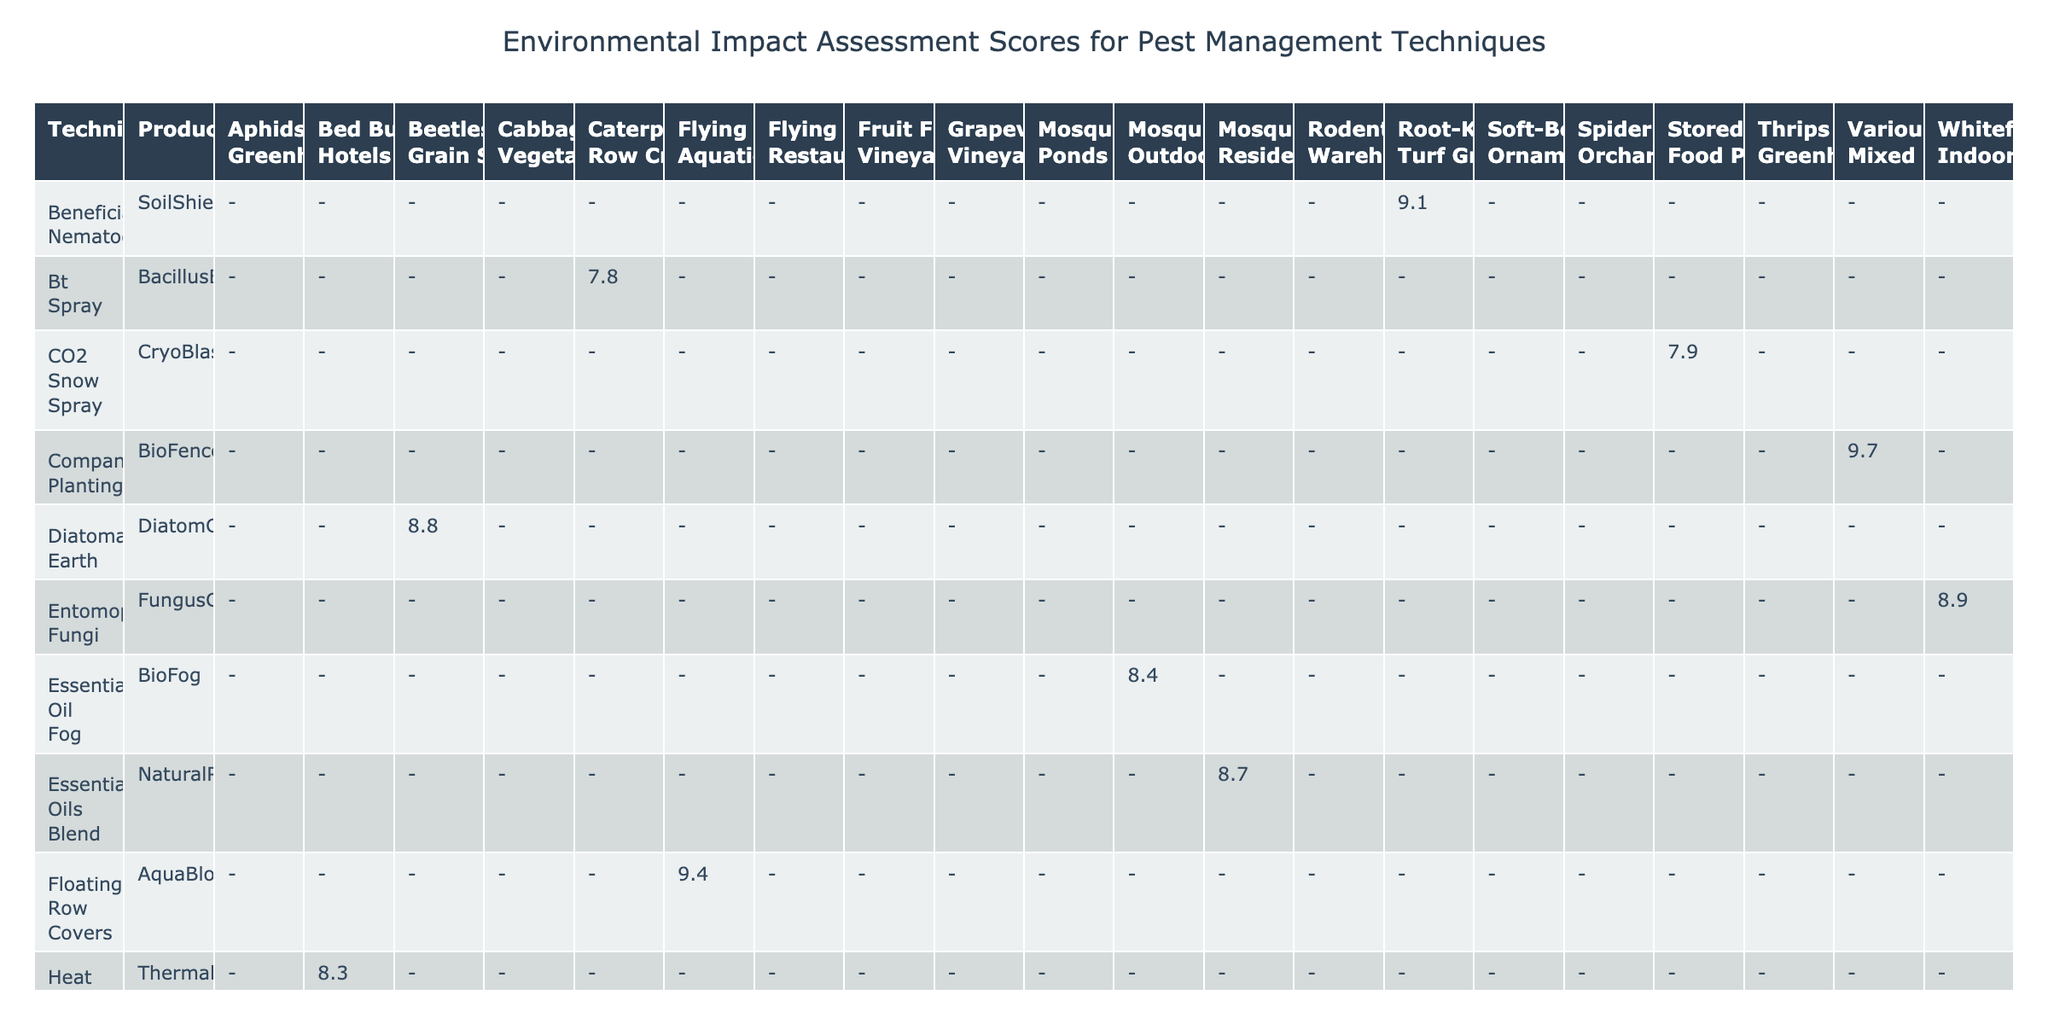What is the environmental impact score of BioNeem? The table lists the product BioNeem under the column for Technique and shows its Environmental Impact Score as 8.5.
Answer: 8.5 Which pest management technique has the highest environmental impact score? By examining the scores of all techniques, BioFence is listed with the highest score of 9.7.
Answer: 9.7 Are there any techniques that have a toxicity to non-targets classified as "None"? Looking at the Toxicity to Non-Targets column, several techniques including EcoMite, ScentBarrier, BeneBug, SoilShield, AquaBlock, and more, all indicate "None." Therefore, the answer is yes.
Answer: Yes What is the average environmental impact score of techniques targeting mosquitoes? There are three techniques targeting mosquitoes: NaturalRepel (8.7), BioFog (8.4), and AquaNet (8.7). The sum of the scores is 8.7 + 8.4 + 8.7 = 25.8. Since there are three techniques, the average is 25.8 / 3 = 8.6.
Answer: 8.6 Is there a pest management technique that has a low biodegradability score? Based on the table, AquaBlock is the only technique listed with a low biodegradability score.
Answer: Yes Which pest management technique specifically addresses fruit flies? The table indicates that ScentBarrier targets fruit flies and has an Environmental Impact Score of 9.5.
Answer: ScentBarrier 